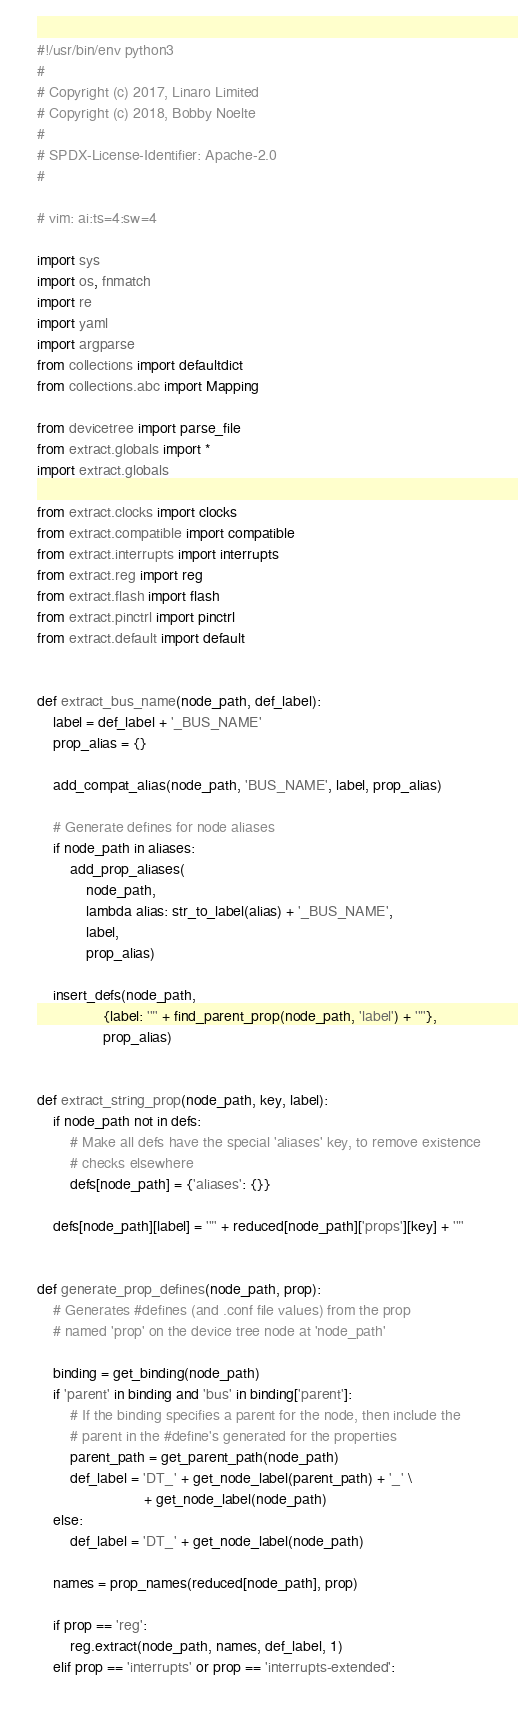Convert code to text. <code><loc_0><loc_0><loc_500><loc_500><_Python_>#!/usr/bin/env python3
#
# Copyright (c) 2017, Linaro Limited
# Copyright (c) 2018, Bobby Noelte
#
# SPDX-License-Identifier: Apache-2.0
#

# vim: ai:ts=4:sw=4

import sys
import os, fnmatch
import re
import yaml
import argparse
from collections import defaultdict
from collections.abc import Mapping

from devicetree import parse_file
from extract.globals import *
import extract.globals

from extract.clocks import clocks
from extract.compatible import compatible
from extract.interrupts import interrupts
from extract.reg import reg
from extract.flash import flash
from extract.pinctrl import pinctrl
from extract.default import default


def extract_bus_name(node_path, def_label):
    label = def_label + '_BUS_NAME'
    prop_alias = {}

    add_compat_alias(node_path, 'BUS_NAME', label, prop_alias)

    # Generate defines for node aliases
    if node_path in aliases:
        add_prop_aliases(
            node_path,
            lambda alias: str_to_label(alias) + '_BUS_NAME',
            label,
            prop_alias)

    insert_defs(node_path,
                {label: '"' + find_parent_prop(node_path, 'label') + '"'},
                prop_alias)


def extract_string_prop(node_path, key, label):
    if node_path not in defs:
        # Make all defs have the special 'aliases' key, to remove existence
        # checks elsewhere
        defs[node_path] = {'aliases': {}}

    defs[node_path][label] = '"' + reduced[node_path]['props'][key] + '"'


def generate_prop_defines(node_path, prop):
    # Generates #defines (and .conf file values) from the prop
    # named 'prop' on the device tree node at 'node_path'

    binding = get_binding(node_path)
    if 'parent' in binding and 'bus' in binding['parent']:
        # If the binding specifies a parent for the node, then include the
        # parent in the #define's generated for the properties
        parent_path = get_parent_path(node_path)
        def_label = 'DT_' + get_node_label(parent_path) + '_' \
                          + get_node_label(node_path)
    else:
        def_label = 'DT_' + get_node_label(node_path)

    names = prop_names(reduced[node_path], prop)

    if prop == 'reg':
        reg.extract(node_path, names, def_label, 1)
    elif prop == 'interrupts' or prop == 'interrupts-extended':</code> 